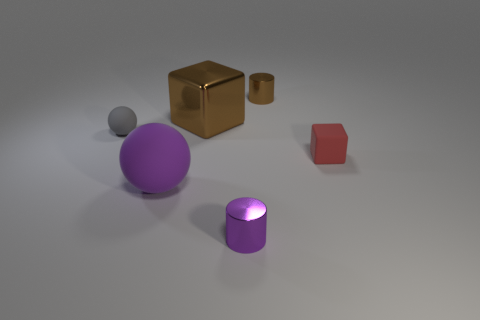Add 1 large purple matte spheres. How many objects exist? 7 Subtract all cylinders. How many objects are left? 4 Subtract 0 yellow balls. How many objects are left? 6 Subtract all brown metallic objects. Subtract all matte spheres. How many objects are left? 2 Add 4 matte balls. How many matte balls are left? 6 Add 3 green objects. How many green objects exist? 3 